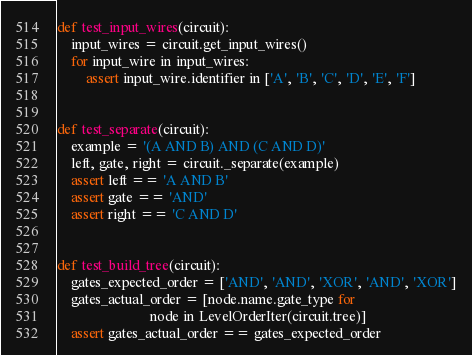Convert code to text. <code><loc_0><loc_0><loc_500><loc_500><_Python_>

def test_input_wires(circuit):
    input_wires = circuit.get_input_wires()
    for input_wire in input_wires:
        assert input_wire.identifier in ['A', 'B', 'C', 'D', 'E', 'F']


def test_separate(circuit):
    example = '(A AND B) AND (C AND D)'
    left, gate, right = circuit._separate(example)
    assert left == 'A AND B'
    assert gate == 'AND'
    assert right == 'C AND D'


def test_build_tree(circuit):
    gates_expected_order = ['AND', 'AND', 'XOR', 'AND', 'XOR']
    gates_actual_order = [node.name.gate_type for
                          node in LevelOrderIter(circuit.tree)]
    assert gates_actual_order == gates_expected_order
</code> 